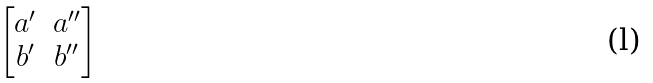<formula> <loc_0><loc_0><loc_500><loc_500>\begin{bmatrix} a ^ { \prime } & a ^ { \prime \prime } \\ b ^ { \prime } & b ^ { \prime \prime } \end{bmatrix}</formula> 